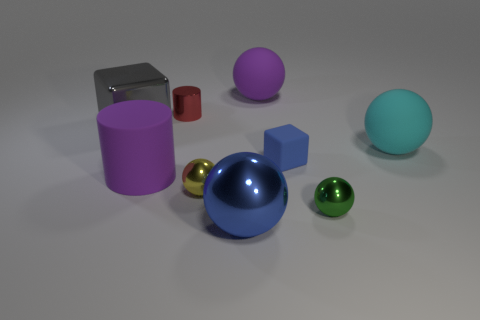Can you describe the lighting and shadows in this scene? The lighting in this scene is soft and diffused, suggesting an overhead light source that is not directly visible. It casts subtle shadows that extend opposite the objects, providing depth and dimension to the composition. The elongated shape of the shadows indicates that the light may be angled slightly, while the soft edges suggest the light source has a broad spread. 